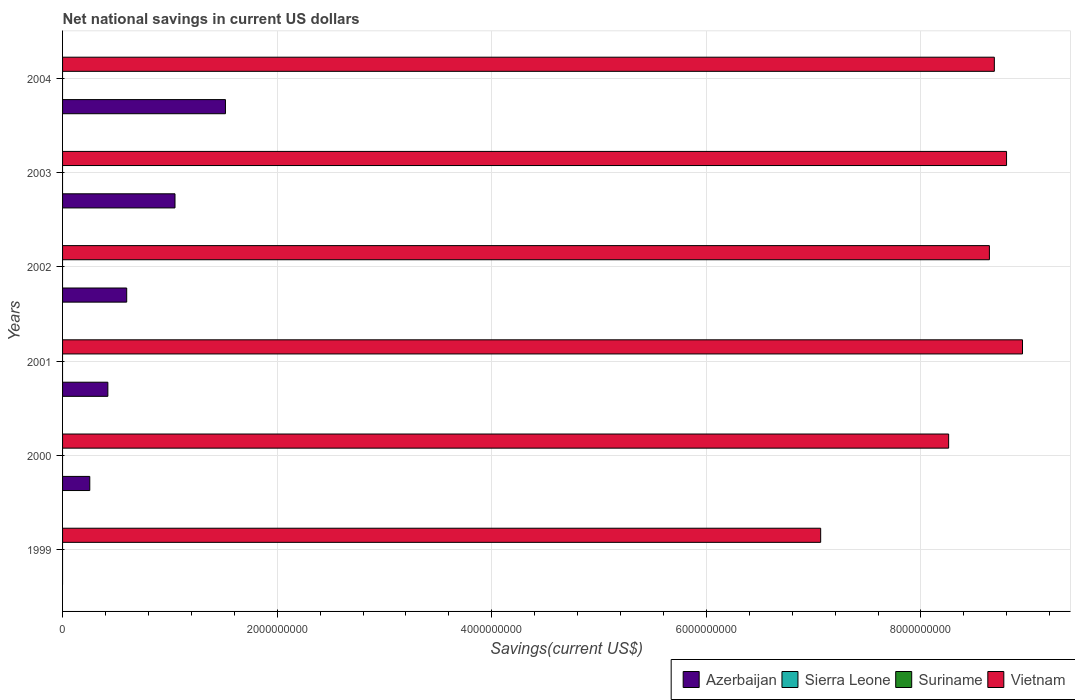How many different coloured bars are there?
Provide a short and direct response. 2. Are the number of bars per tick equal to the number of legend labels?
Provide a short and direct response. No. Are the number of bars on each tick of the Y-axis equal?
Keep it short and to the point. No. How many bars are there on the 4th tick from the top?
Keep it short and to the point. 2. What is the label of the 2nd group of bars from the top?
Your answer should be compact. 2003. In how many cases, is the number of bars for a given year not equal to the number of legend labels?
Give a very brief answer. 6. What is the net national savings in Vietnam in 2001?
Keep it short and to the point. 8.95e+09. Across all years, what is the maximum net national savings in Vietnam?
Your answer should be compact. 8.95e+09. Across all years, what is the minimum net national savings in Azerbaijan?
Provide a short and direct response. 0. In which year was the net national savings in Vietnam maximum?
Provide a succinct answer. 2001. What is the total net national savings in Suriname in the graph?
Make the answer very short. 0. What is the difference between the net national savings in Azerbaijan in 2000 and that in 2004?
Provide a short and direct response. -1.26e+09. What is the difference between the net national savings in Azerbaijan in 1999 and the net national savings in Vietnam in 2003?
Your response must be concise. -8.80e+09. In the year 2001, what is the difference between the net national savings in Azerbaijan and net national savings in Vietnam?
Ensure brevity in your answer.  -8.52e+09. In how many years, is the net national savings in Suriname greater than 8000000000 US$?
Ensure brevity in your answer.  0. What is the ratio of the net national savings in Vietnam in 1999 to that in 2001?
Offer a very short reply. 0.79. What is the difference between the highest and the second highest net national savings in Vietnam?
Offer a very short reply. 1.49e+08. What is the difference between the highest and the lowest net national savings in Vietnam?
Provide a short and direct response. 1.88e+09. In how many years, is the net national savings in Sierra Leone greater than the average net national savings in Sierra Leone taken over all years?
Your response must be concise. 0. Is it the case that in every year, the sum of the net national savings in Sierra Leone and net national savings in Azerbaijan is greater than the sum of net national savings in Vietnam and net national savings in Suriname?
Ensure brevity in your answer.  No. Is it the case that in every year, the sum of the net national savings in Sierra Leone and net national savings in Vietnam is greater than the net national savings in Azerbaijan?
Make the answer very short. Yes. Are all the bars in the graph horizontal?
Your response must be concise. Yes. Are the values on the major ticks of X-axis written in scientific E-notation?
Make the answer very short. No. Does the graph contain any zero values?
Offer a very short reply. Yes. Does the graph contain grids?
Ensure brevity in your answer.  Yes. Where does the legend appear in the graph?
Your answer should be very brief. Bottom right. How are the legend labels stacked?
Ensure brevity in your answer.  Horizontal. What is the title of the graph?
Ensure brevity in your answer.  Net national savings in current US dollars. What is the label or title of the X-axis?
Your answer should be very brief. Savings(current US$). What is the label or title of the Y-axis?
Make the answer very short. Years. What is the Savings(current US$) of Vietnam in 1999?
Your response must be concise. 7.07e+09. What is the Savings(current US$) of Azerbaijan in 2000?
Offer a terse response. 2.54e+08. What is the Savings(current US$) in Sierra Leone in 2000?
Your answer should be compact. 0. What is the Savings(current US$) of Suriname in 2000?
Keep it short and to the point. 0. What is the Savings(current US$) of Vietnam in 2000?
Make the answer very short. 8.26e+09. What is the Savings(current US$) of Azerbaijan in 2001?
Offer a terse response. 4.22e+08. What is the Savings(current US$) in Sierra Leone in 2001?
Offer a very short reply. 0. What is the Savings(current US$) of Suriname in 2001?
Offer a terse response. 0. What is the Savings(current US$) of Vietnam in 2001?
Give a very brief answer. 8.95e+09. What is the Savings(current US$) of Azerbaijan in 2002?
Make the answer very short. 5.98e+08. What is the Savings(current US$) in Suriname in 2002?
Your answer should be very brief. 0. What is the Savings(current US$) of Vietnam in 2002?
Your answer should be compact. 8.64e+09. What is the Savings(current US$) of Azerbaijan in 2003?
Provide a succinct answer. 1.05e+09. What is the Savings(current US$) of Sierra Leone in 2003?
Ensure brevity in your answer.  0. What is the Savings(current US$) in Vietnam in 2003?
Your answer should be very brief. 8.80e+09. What is the Savings(current US$) in Azerbaijan in 2004?
Offer a very short reply. 1.52e+09. What is the Savings(current US$) in Sierra Leone in 2004?
Keep it short and to the point. 0. What is the Savings(current US$) of Vietnam in 2004?
Make the answer very short. 8.68e+09. Across all years, what is the maximum Savings(current US$) of Azerbaijan?
Provide a succinct answer. 1.52e+09. Across all years, what is the maximum Savings(current US$) in Vietnam?
Your answer should be compact. 8.95e+09. Across all years, what is the minimum Savings(current US$) of Azerbaijan?
Your response must be concise. 0. Across all years, what is the minimum Savings(current US$) in Vietnam?
Provide a short and direct response. 7.07e+09. What is the total Savings(current US$) in Azerbaijan in the graph?
Provide a succinct answer. 3.84e+09. What is the total Savings(current US$) in Suriname in the graph?
Your response must be concise. 0. What is the total Savings(current US$) in Vietnam in the graph?
Your response must be concise. 5.04e+1. What is the difference between the Savings(current US$) in Vietnam in 1999 and that in 2000?
Provide a short and direct response. -1.19e+09. What is the difference between the Savings(current US$) in Vietnam in 1999 and that in 2001?
Provide a short and direct response. -1.88e+09. What is the difference between the Savings(current US$) in Vietnam in 1999 and that in 2002?
Offer a very short reply. -1.57e+09. What is the difference between the Savings(current US$) of Vietnam in 1999 and that in 2003?
Your response must be concise. -1.73e+09. What is the difference between the Savings(current US$) in Vietnam in 1999 and that in 2004?
Offer a terse response. -1.62e+09. What is the difference between the Savings(current US$) in Azerbaijan in 2000 and that in 2001?
Provide a succinct answer. -1.68e+08. What is the difference between the Savings(current US$) in Vietnam in 2000 and that in 2001?
Provide a short and direct response. -6.88e+08. What is the difference between the Savings(current US$) in Azerbaijan in 2000 and that in 2002?
Ensure brevity in your answer.  -3.44e+08. What is the difference between the Savings(current US$) in Vietnam in 2000 and that in 2002?
Offer a very short reply. -3.80e+08. What is the difference between the Savings(current US$) of Azerbaijan in 2000 and that in 2003?
Your response must be concise. -7.94e+08. What is the difference between the Savings(current US$) in Vietnam in 2000 and that in 2003?
Your answer should be very brief. -5.40e+08. What is the difference between the Savings(current US$) of Azerbaijan in 2000 and that in 2004?
Your answer should be very brief. -1.26e+09. What is the difference between the Savings(current US$) of Vietnam in 2000 and that in 2004?
Provide a succinct answer. -4.26e+08. What is the difference between the Savings(current US$) of Azerbaijan in 2001 and that in 2002?
Your response must be concise. -1.76e+08. What is the difference between the Savings(current US$) in Vietnam in 2001 and that in 2002?
Provide a short and direct response. 3.08e+08. What is the difference between the Savings(current US$) of Azerbaijan in 2001 and that in 2003?
Give a very brief answer. -6.26e+08. What is the difference between the Savings(current US$) of Vietnam in 2001 and that in 2003?
Offer a very short reply. 1.49e+08. What is the difference between the Savings(current US$) of Azerbaijan in 2001 and that in 2004?
Offer a terse response. -1.10e+09. What is the difference between the Savings(current US$) in Vietnam in 2001 and that in 2004?
Your answer should be compact. 2.62e+08. What is the difference between the Savings(current US$) in Azerbaijan in 2002 and that in 2003?
Provide a short and direct response. -4.50e+08. What is the difference between the Savings(current US$) of Vietnam in 2002 and that in 2003?
Your response must be concise. -1.60e+08. What is the difference between the Savings(current US$) of Azerbaijan in 2002 and that in 2004?
Your response must be concise. -9.20e+08. What is the difference between the Savings(current US$) in Vietnam in 2002 and that in 2004?
Provide a succinct answer. -4.60e+07. What is the difference between the Savings(current US$) of Azerbaijan in 2003 and that in 2004?
Offer a very short reply. -4.70e+08. What is the difference between the Savings(current US$) in Vietnam in 2003 and that in 2004?
Ensure brevity in your answer.  1.14e+08. What is the difference between the Savings(current US$) of Azerbaijan in 2000 and the Savings(current US$) of Vietnam in 2001?
Offer a very short reply. -8.69e+09. What is the difference between the Savings(current US$) of Azerbaijan in 2000 and the Savings(current US$) of Vietnam in 2002?
Offer a terse response. -8.38e+09. What is the difference between the Savings(current US$) in Azerbaijan in 2000 and the Savings(current US$) in Vietnam in 2003?
Your response must be concise. -8.54e+09. What is the difference between the Savings(current US$) in Azerbaijan in 2000 and the Savings(current US$) in Vietnam in 2004?
Your answer should be compact. -8.43e+09. What is the difference between the Savings(current US$) of Azerbaijan in 2001 and the Savings(current US$) of Vietnam in 2002?
Offer a very short reply. -8.22e+09. What is the difference between the Savings(current US$) of Azerbaijan in 2001 and the Savings(current US$) of Vietnam in 2003?
Ensure brevity in your answer.  -8.38e+09. What is the difference between the Savings(current US$) in Azerbaijan in 2001 and the Savings(current US$) in Vietnam in 2004?
Provide a short and direct response. -8.26e+09. What is the difference between the Savings(current US$) in Azerbaijan in 2002 and the Savings(current US$) in Vietnam in 2003?
Make the answer very short. -8.20e+09. What is the difference between the Savings(current US$) of Azerbaijan in 2002 and the Savings(current US$) of Vietnam in 2004?
Provide a short and direct response. -8.09e+09. What is the difference between the Savings(current US$) of Azerbaijan in 2003 and the Savings(current US$) of Vietnam in 2004?
Provide a short and direct response. -7.64e+09. What is the average Savings(current US$) of Azerbaijan per year?
Ensure brevity in your answer.  6.40e+08. What is the average Savings(current US$) in Sierra Leone per year?
Your response must be concise. 0. What is the average Savings(current US$) in Suriname per year?
Keep it short and to the point. 0. What is the average Savings(current US$) of Vietnam per year?
Make the answer very short. 8.40e+09. In the year 2000, what is the difference between the Savings(current US$) of Azerbaijan and Savings(current US$) of Vietnam?
Keep it short and to the point. -8.00e+09. In the year 2001, what is the difference between the Savings(current US$) in Azerbaijan and Savings(current US$) in Vietnam?
Your answer should be compact. -8.52e+09. In the year 2002, what is the difference between the Savings(current US$) of Azerbaijan and Savings(current US$) of Vietnam?
Your answer should be very brief. -8.04e+09. In the year 2003, what is the difference between the Savings(current US$) of Azerbaijan and Savings(current US$) of Vietnam?
Make the answer very short. -7.75e+09. In the year 2004, what is the difference between the Savings(current US$) in Azerbaijan and Savings(current US$) in Vietnam?
Ensure brevity in your answer.  -7.17e+09. What is the ratio of the Savings(current US$) in Vietnam in 1999 to that in 2000?
Your answer should be compact. 0.86. What is the ratio of the Savings(current US$) of Vietnam in 1999 to that in 2001?
Your answer should be compact. 0.79. What is the ratio of the Savings(current US$) in Vietnam in 1999 to that in 2002?
Your answer should be very brief. 0.82. What is the ratio of the Savings(current US$) in Vietnam in 1999 to that in 2003?
Your answer should be compact. 0.8. What is the ratio of the Savings(current US$) in Vietnam in 1999 to that in 2004?
Your answer should be very brief. 0.81. What is the ratio of the Savings(current US$) of Azerbaijan in 2000 to that in 2001?
Give a very brief answer. 0.6. What is the ratio of the Savings(current US$) of Azerbaijan in 2000 to that in 2002?
Offer a terse response. 0.42. What is the ratio of the Savings(current US$) of Vietnam in 2000 to that in 2002?
Your answer should be very brief. 0.96. What is the ratio of the Savings(current US$) of Azerbaijan in 2000 to that in 2003?
Give a very brief answer. 0.24. What is the ratio of the Savings(current US$) in Vietnam in 2000 to that in 2003?
Your answer should be compact. 0.94. What is the ratio of the Savings(current US$) in Azerbaijan in 2000 to that in 2004?
Make the answer very short. 0.17. What is the ratio of the Savings(current US$) in Vietnam in 2000 to that in 2004?
Provide a short and direct response. 0.95. What is the ratio of the Savings(current US$) in Azerbaijan in 2001 to that in 2002?
Make the answer very short. 0.71. What is the ratio of the Savings(current US$) in Vietnam in 2001 to that in 2002?
Keep it short and to the point. 1.04. What is the ratio of the Savings(current US$) of Azerbaijan in 2001 to that in 2003?
Offer a terse response. 0.4. What is the ratio of the Savings(current US$) of Vietnam in 2001 to that in 2003?
Provide a succinct answer. 1.02. What is the ratio of the Savings(current US$) of Azerbaijan in 2001 to that in 2004?
Keep it short and to the point. 0.28. What is the ratio of the Savings(current US$) of Vietnam in 2001 to that in 2004?
Give a very brief answer. 1.03. What is the ratio of the Savings(current US$) in Azerbaijan in 2002 to that in 2003?
Ensure brevity in your answer.  0.57. What is the ratio of the Savings(current US$) of Vietnam in 2002 to that in 2003?
Ensure brevity in your answer.  0.98. What is the ratio of the Savings(current US$) in Azerbaijan in 2002 to that in 2004?
Give a very brief answer. 0.39. What is the ratio of the Savings(current US$) in Azerbaijan in 2003 to that in 2004?
Your answer should be compact. 0.69. What is the ratio of the Savings(current US$) of Vietnam in 2003 to that in 2004?
Your answer should be very brief. 1.01. What is the difference between the highest and the second highest Savings(current US$) in Azerbaijan?
Offer a very short reply. 4.70e+08. What is the difference between the highest and the second highest Savings(current US$) in Vietnam?
Ensure brevity in your answer.  1.49e+08. What is the difference between the highest and the lowest Savings(current US$) of Azerbaijan?
Your response must be concise. 1.52e+09. What is the difference between the highest and the lowest Savings(current US$) of Vietnam?
Keep it short and to the point. 1.88e+09. 